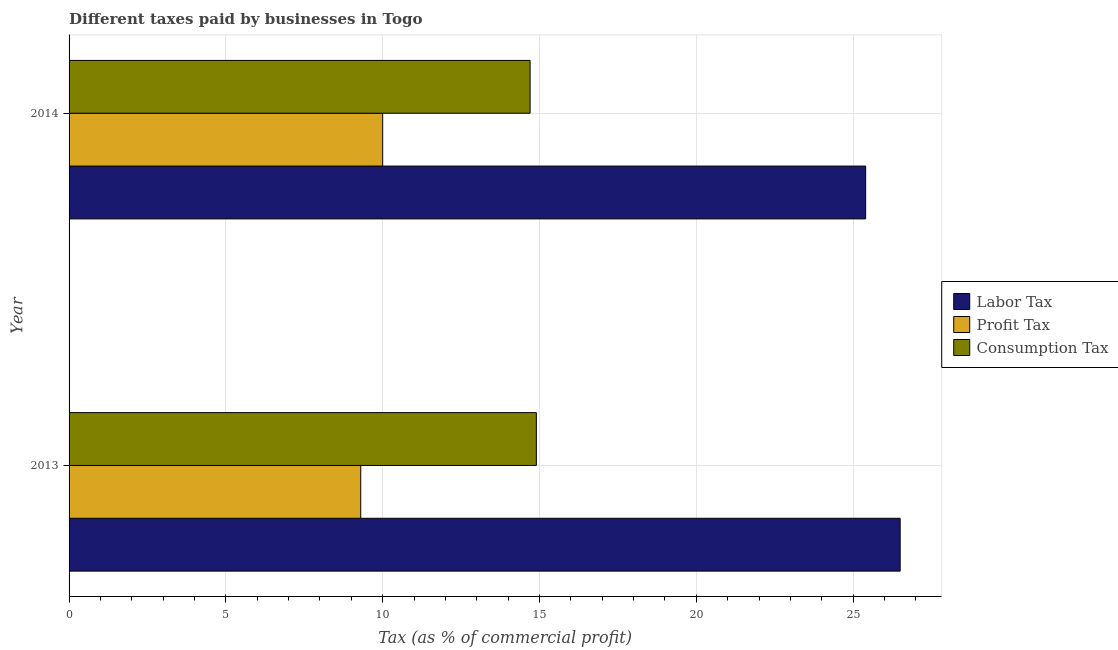How many groups of bars are there?
Keep it short and to the point. 2. Are the number of bars per tick equal to the number of legend labels?
Give a very brief answer. Yes. Are the number of bars on each tick of the Y-axis equal?
Your response must be concise. Yes. How many bars are there on the 1st tick from the top?
Your answer should be compact. 3. How many bars are there on the 1st tick from the bottom?
Ensure brevity in your answer.  3. What is the percentage of profit tax in 2013?
Offer a very short reply. 9.3. In which year was the percentage of profit tax maximum?
Offer a very short reply. 2014. In which year was the percentage of labor tax minimum?
Give a very brief answer. 2014. What is the total percentage of labor tax in the graph?
Your response must be concise. 51.9. What is the difference between the percentage of consumption tax in 2013 and the percentage of labor tax in 2014?
Give a very brief answer. -10.5. What is the average percentage of labor tax per year?
Your response must be concise. 25.95. In how many years, is the percentage of consumption tax greater than 1 %?
Offer a terse response. 2. What is the ratio of the percentage of labor tax in 2013 to that in 2014?
Your answer should be compact. 1.04. Is the percentage of labor tax in 2013 less than that in 2014?
Your answer should be compact. No. Is the difference between the percentage of profit tax in 2013 and 2014 greater than the difference between the percentage of labor tax in 2013 and 2014?
Ensure brevity in your answer.  No. In how many years, is the percentage of profit tax greater than the average percentage of profit tax taken over all years?
Offer a terse response. 1. What does the 2nd bar from the top in 2013 represents?
Ensure brevity in your answer.  Profit Tax. What does the 2nd bar from the bottom in 2014 represents?
Make the answer very short. Profit Tax. Are all the bars in the graph horizontal?
Provide a short and direct response. Yes. How many years are there in the graph?
Offer a very short reply. 2. What is the difference between two consecutive major ticks on the X-axis?
Provide a short and direct response. 5. Are the values on the major ticks of X-axis written in scientific E-notation?
Keep it short and to the point. No. Does the graph contain grids?
Your answer should be compact. Yes. Where does the legend appear in the graph?
Give a very brief answer. Center right. How many legend labels are there?
Make the answer very short. 3. What is the title of the graph?
Your answer should be very brief. Different taxes paid by businesses in Togo. Does "Tertiary" appear as one of the legend labels in the graph?
Make the answer very short. No. What is the label or title of the X-axis?
Make the answer very short. Tax (as % of commercial profit). What is the label or title of the Y-axis?
Your response must be concise. Year. What is the Tax (as % of commercial profit) of Labor Tax in 2013?
Your answer should be compact. 26.5. What is the Tax (as % of commercial profit) in Consumption Tax in 2013?
Provide a short and direct response. 14.9. What is the Tax (as % of commercial profit) in Labor Tax in 2014?
Provide a short and direct response. 25.4. What is the Tax (as % of commercial profit) of Profit Tax in 2014?
Your answer should be very brief. 10. What is the Tax (as % of commercial profit) of Consumption Tax in 2014?
Provide a succinct answer. 14.7. Across all years, what is the maximum Tax (as % of commercial profit) in Labor Tax?
Offer a very short reply. 26.5. Across all years, what is the minimum Tax (as % of commercial profit) of Labor Tax?
Provide a short and direct response. 25.4. Across all years, what is the minimum Tax (as % of commercial profit) in Consumption Tax?
Offer a terse response. 14.7. What is the total Tax (as % of commercial profit) in Labor Tax in the graph?
Offer a very short reply. 51.9. What is the total Tax (as % of commercial profit) in Profit Tax in the graph?
Your response must be concise. 19.3. What is the total Tax (as % of commercial profit) in Consumption Tax in the graph?
Give a very brief answer. 29.6. What is the difference between the Tax (as % of commercial profit) of Profit Tax in 2013 and that in 2014?
Make the answer very short. -0.7. What is the difference between the Tax (as % of commercial profit) in Labor Tax in 2013 and the Tax (as % of commercial profit) in Consumption Tax in 2014?
Make the answer very short. 11.8. What is the difference between the Tax (as % of commercial profit) of Profit Tax in 2013 and the Tax (as % of commercial profit) of Consumption Tax in 2014?
Offer a terse response. -5.4. What is the average Tax (as % of commercial profit) of Labor Tax per year?
Offer a terse response. 25.95. What is the average Tax (as % of commercial profit) of Profit Tax per year?
Make the answer very short. 9.65. In the year 2013, what is the difference between the Tax (as % of commercial profit) of Labor Tax and Tax (as % of commercial profit) of Profit Tax?
Your response must be concise. 17.2. In the year 2013, what is the difference between the Tax (as % of commercial profit) of Profit Tax and Tax (as % of commercial profit) of Consumption Tax?
Offer a very short reply. -5.6. In the year 2014, what is the difference between the Tax (as % of commercial profit) in Labor Tax and Tax (as % of commercial profit) in Consumption Tax?
Provide a succinct answer. 10.7. What is the ratio of the Tax (as % of commercial profit) in Labor Tax in 2013 to that in 2014?
Your answer should be very brief. 1.04. What is the ratio of the Tax (as % of commercial profit) in Profit Tax in 2013 to that in 2014?
Make the answer very short. 0.93. What is the ratio of the Tax (as % of commercial profit) of Consumption Tax in 2013 to that in 2014?
Give a very brief answer. 1.01. What is the difference between the highest and the second highest Tax (as % of commercial profit) of Labor Tax?
Offer a terse response. 1.1. What is the difference between the highest and the lowest Tax (as % of commercial profit) of Labor Tax?
Ensure brevity in your answer.  1.1. What is the difference between the highest and the lowest Tax (as % of commercial profit) in Profit Tax?
Give a very brief answer. 0.7. What is the difference between the highest and the lowest Tax (as % of commercial profit) in Consumption Tax?
Ensure brevity in your answer.  0.2. 